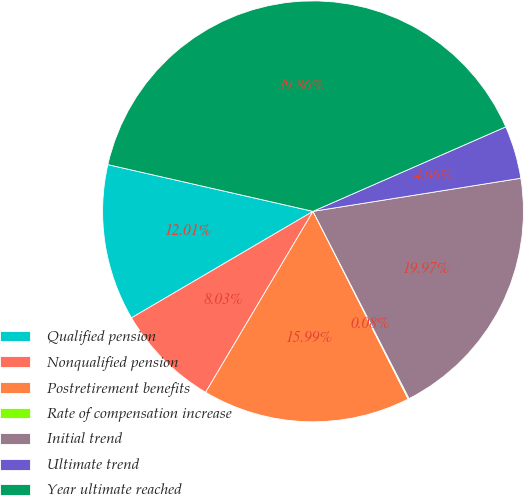Convert chart to OTSL. <chart><loc_0><loc_0><loc_500><loc_500><pie_chart><fcel>Qualified pension<fcel>Nonqualified pension<fcel>Postretirement benefits<fcel>Rate of compensation increase<fcel>Initial trend<fcel>Ultimate trend<fcel>Year ultimate reached<nl><fcel>12.01%<fcel>8.03%<fcel>15.99%<fcel>0.08%<fcel>19.97%<fcel>4.06%<fcel>39.86%<nl></chart> 